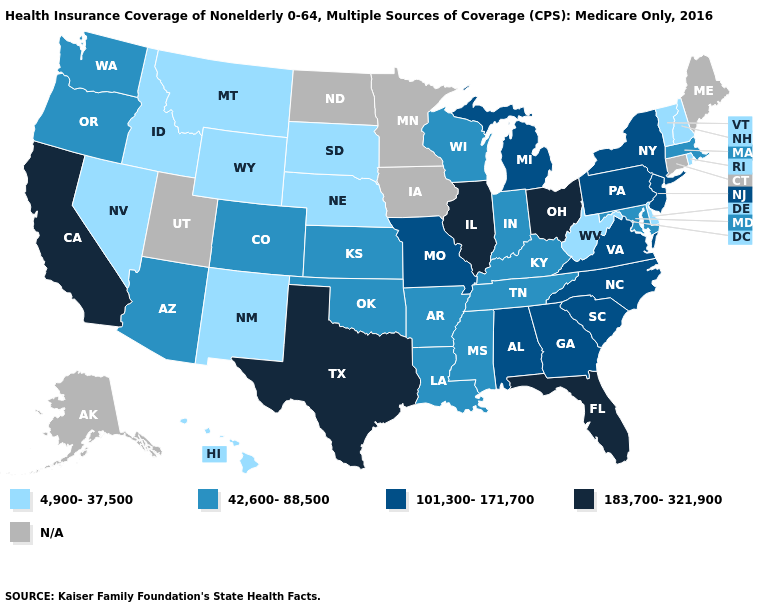Does Kentucky have the lowest value in the USA?
Quick response, please. No. Does the first symbol in the legend represent the smallest category?
Answer briefly. Yes. Which states hav the highest value in the West?
Short answer required. California. Name the states that have a value in the range 101,300-171,700?
Write a very short answer. Alabama, Georgia, Michigan, Missouri, New Jersey, New York, North Carolina, Pennsylvania, South Carolina, Virginia. Which states hav the highest value in the West?
Concise answer only. California. Is the legend a continuous bar?
Write a very short answer. No. Name the states that have a value in the range 4,900-37,500?
Quick response, please. Delaware, Hawaii, Idaho, Montana, Nebraska, Nevada, New Hampshire, New Mexico, Rhode Island, South Dakota, Vermont, West Virginia, Wyoming. Name the states that have a value in the range 183,700-321,900?
Write a very short answer. California, Florida, Illinois, Ohio, Texas. Among the states that border Indiana , which have the lowest value?
Give a very brief answer. Kentucky. What is the value of Ohio?
Keep it brief. 183,700-321,900. Name the states that have a value in the range 101,300-171,700?
Quick response, please. Alabama, Georgia, Michigan, Missouri, New Jersey, New York, North Carolina, Pennsylvania, South Carolina, Virginia. What is the value of Rhode Island?
Short answer required. 4,900-37,500. 